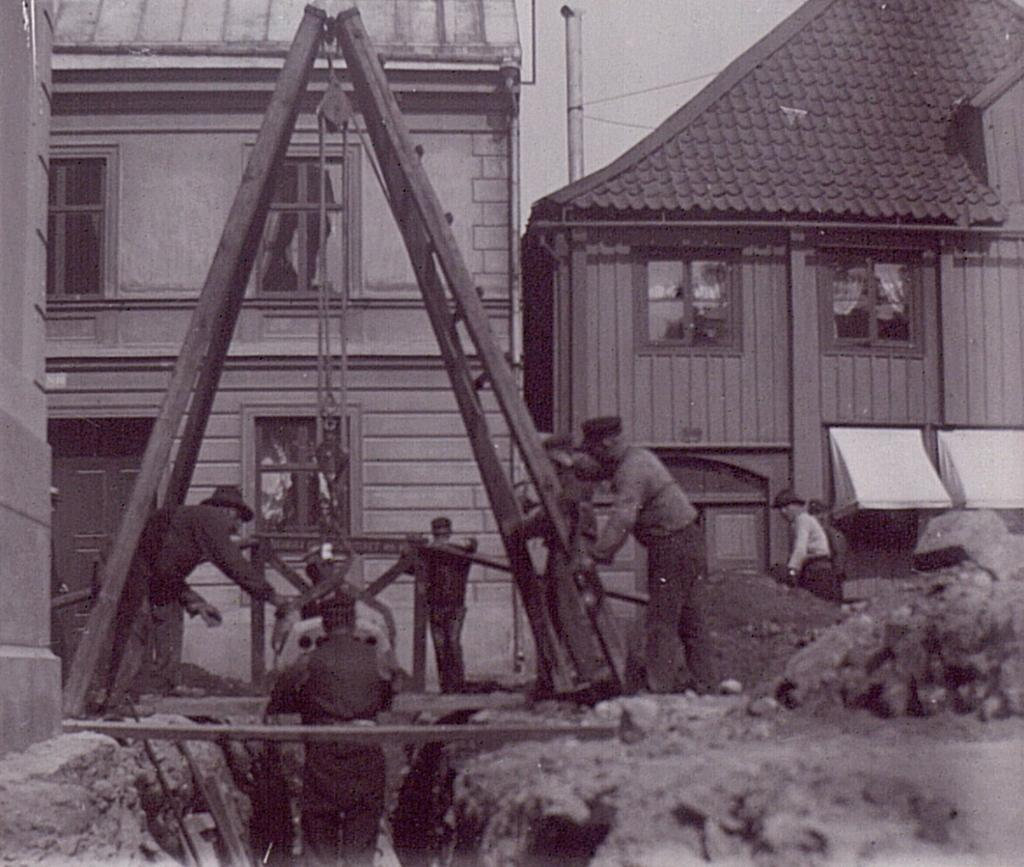What type of structures are visible in the image? There are houses in the image. What can be seen in front of the houses? There are persons in front of the houses. What is located in the middle of the image? There is a stand in the middle of the image. What is on top of the stand? There is a pole on the stand. What is visible in the background of the image? The sky is visible in the image. Can you tell me how many bulbs are attached to the pole in the image? There is no information about bulbs in the image; the pole is mentioned, but no details about any attachments are provided. 